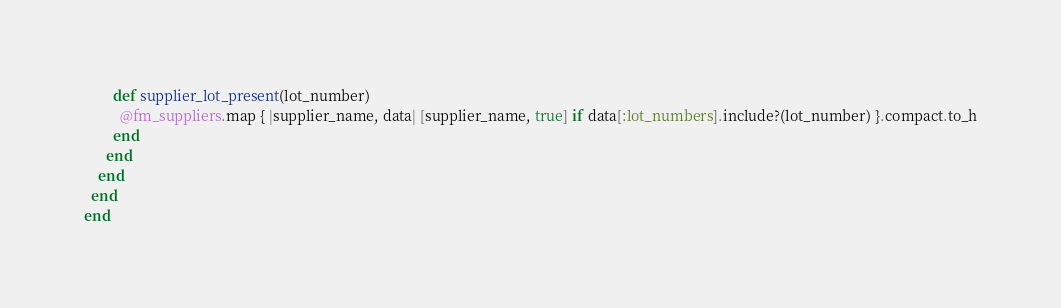<code> <loc_0><loc_0><loc_500><loc_500><_Ruby_>        def supplier_lot_present(lot_number)
          @fm_suppliers.map { |supplier_name, data| [supplier_name, true] if data[:lot_numbers].include?(lot_number) }.compact.to_h
        end
      end
    end
  end
end
</code> 